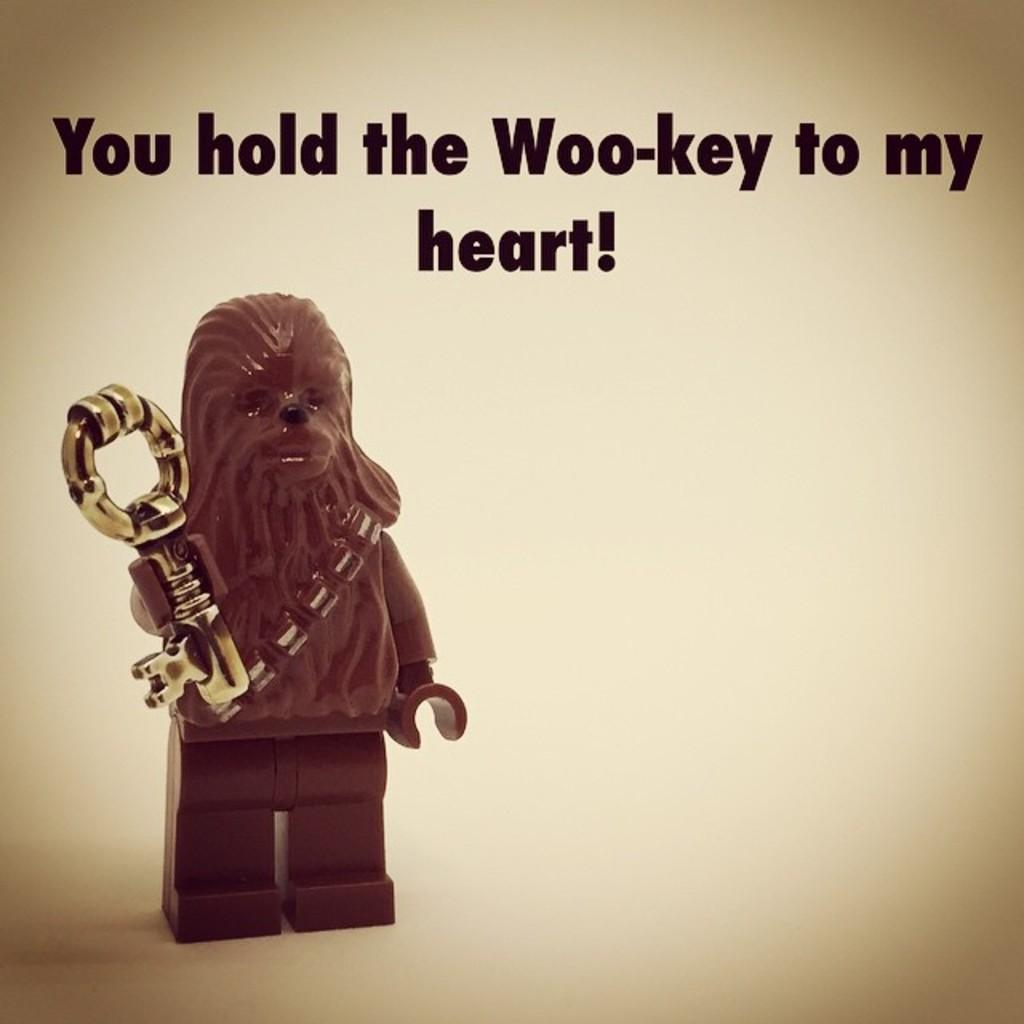What object can be seen in the image? There is a toy in the image. What is the toy holding in its hand? The toy is holding a key in its hand. Where is the toy positioned in the image? The toy is on a platform. Are there any words or phrases written on the image? Yes, there are texts written on the image. Can you see any yaks or bushes in the image? No, there are no yaks or bushes present in the image. What message is the toy conveying as it says good-bye in the image? There is no indication of the toy saying good-bye or conveying any message in the image. 